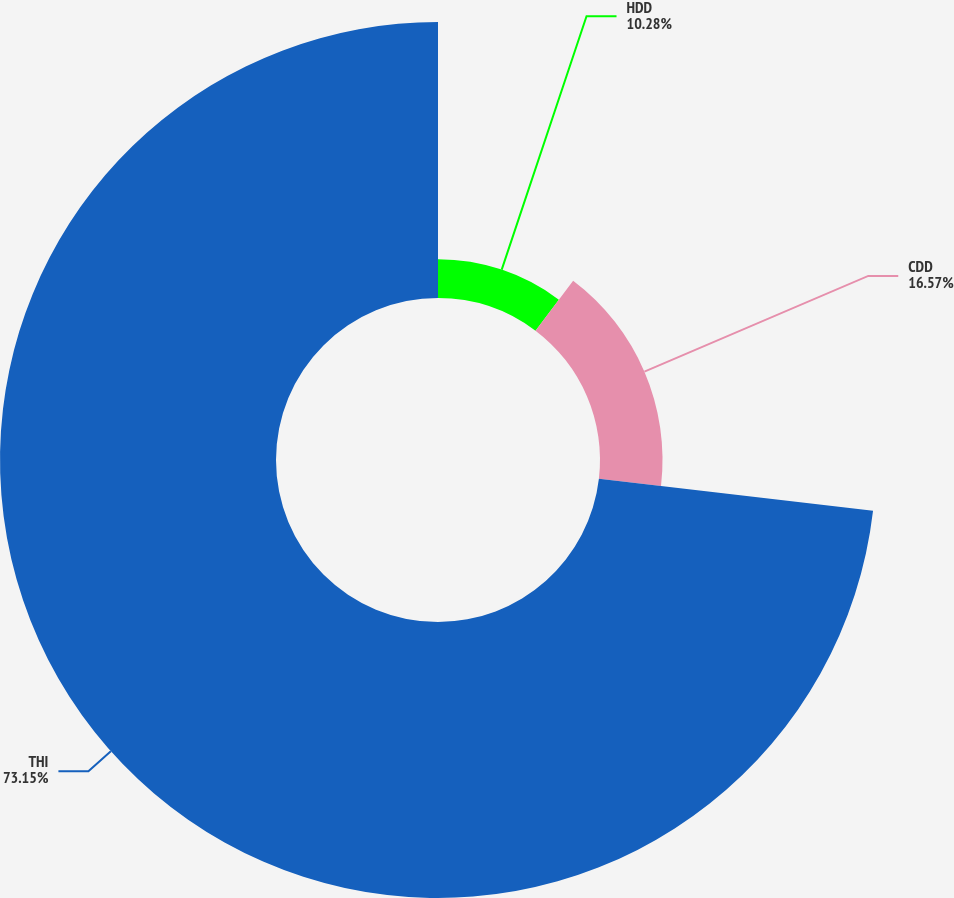Convert chart. <chart><loc_0><loc_0><loc_500><loc_500><pie_chart><fcel>HDD<fcel>CDD<fcel>THI<nl><fcel>10.28%<fcel>16.57%<fcel>73.15%<nl></chart> 